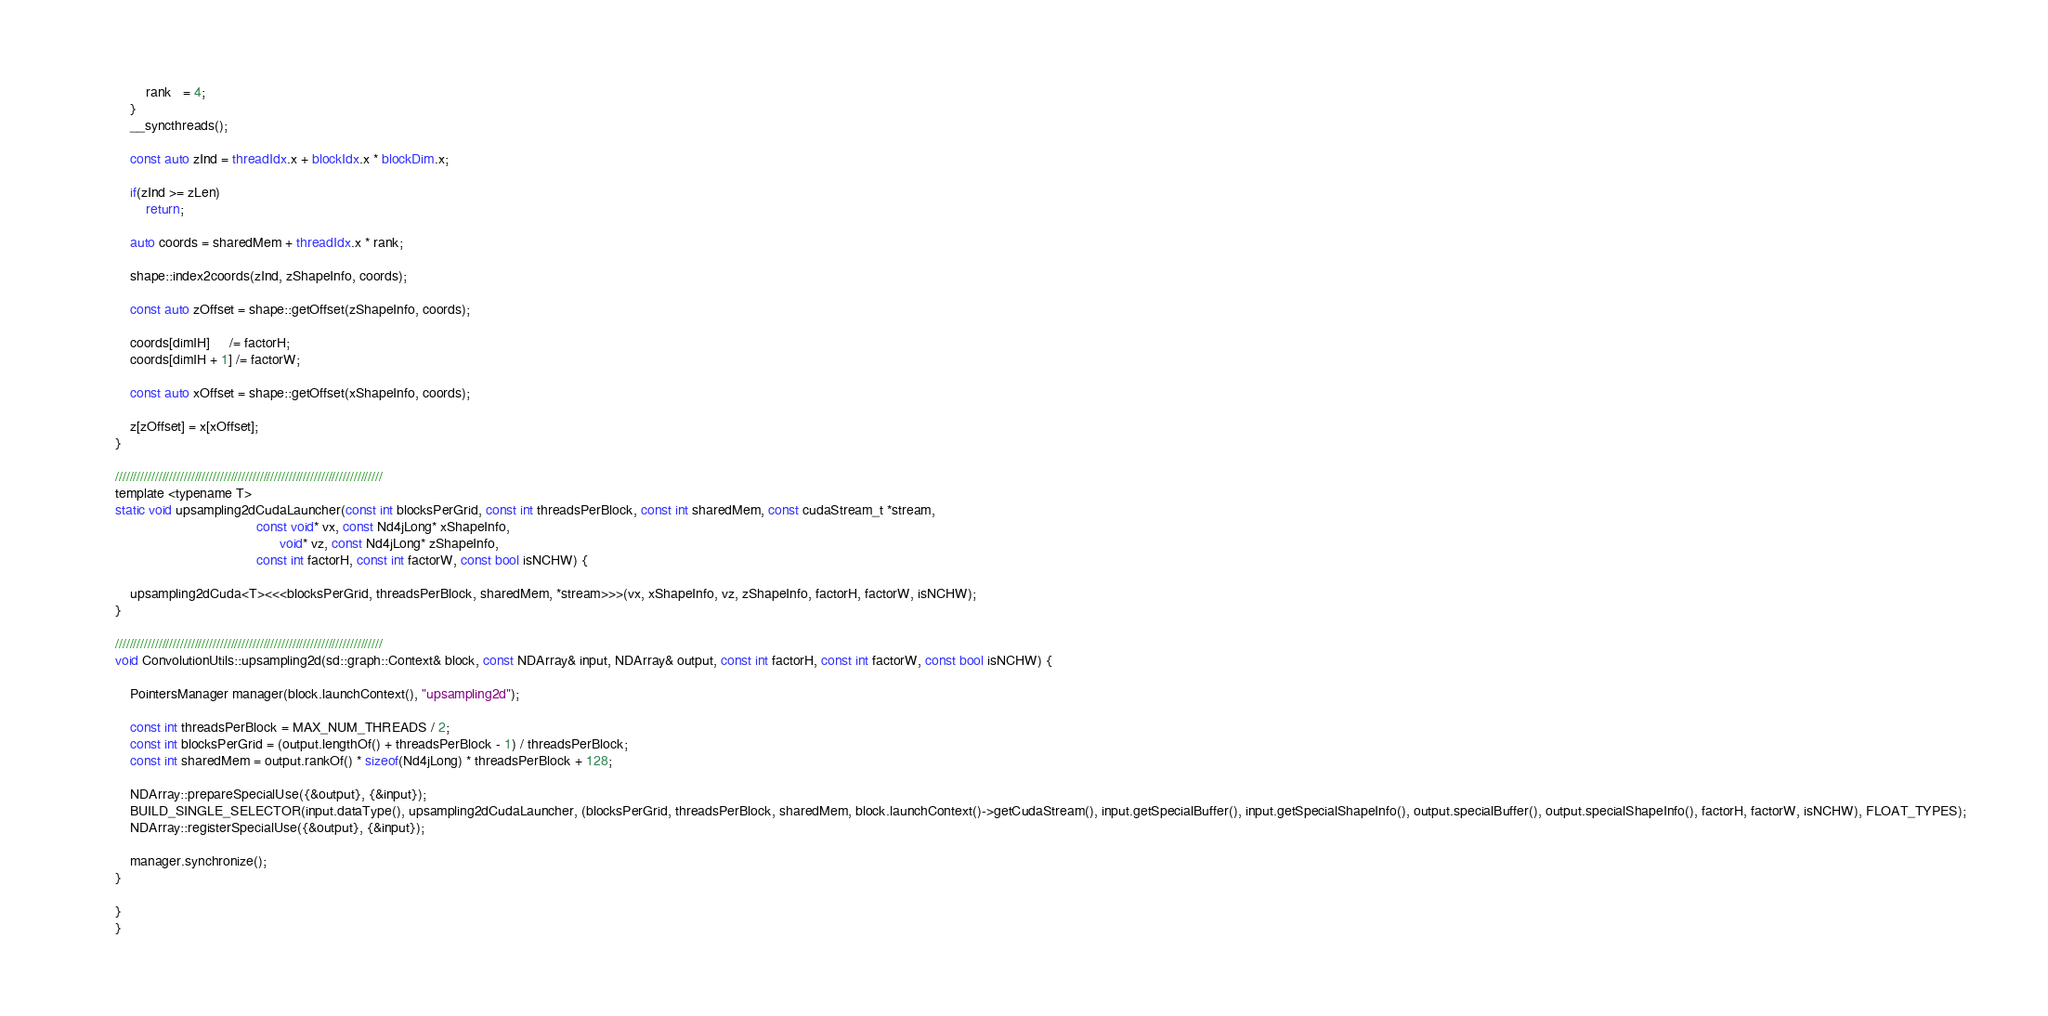<code> <loc_0><loc_0><loc_500><loc_500><_Cuda_>        rank   = 4;
    }
    __syncthreads();

    const auto zInd = threadIdx.x + blockIdx.x * blockDim.x;

    if(zInd >= zLen)
        return;

    auto coords = sharedMem + threadIdx.x * rank;

    shape::index2coords(zInd, zShapeInfo, coords);

    const auto zOffset = shape::getOffset(zShapeInfo, coords);

    coords[dimIH]     /= factorH;
    coords[dimIH + 1] /= factorW;

    const auto xOffset = shape::getOffset(xShapeInfo, coords);

    z[zOffset] = x[xOffset];
}

//////////////////////////////////////////////////////////////////////////
template <typename T>
static void upsampling2dCudaLauncher(const int blocksPerGrid, const int threadsPerBlock, const int sharedMem, const cudaStream_t *stream,
                                     const void* vx, const Nd4jLong* xShapeInfo,
                                           void* vz, const Nd4jLong* zShapeInfo,
                                     const int factorH, const int factorW, const bool isNCHW) {

    upsampling2dCuda<T><<<blocksPerGrid, threadsPerBlock, sharedMem, *stream>>>(vx, xShapeInfo, vz, zShapeInfo, factorH, factorW, isNCHW);
}

//////////////////////////////////////////////////////////////////////////
void ConvolutionUtils::upsampling2d(sd::graph::Context& block, const NDArray& input, NDArray& output, const int factorH, const int factorW, const bool isNCHW) {

    PointersManager manager(block.launchContext(), "upsampling2d");

    const int threadsPerBlock = MAX_NUM_THREADS / 2;
    const int blocksPerGrid = (output.lengthOf() + threadsPerBlock - 1) / threadsPerBlock;
    const int sharedMem = output.rankOf() * sizeof(Nd4jLong) * threadsPerBlock + 128;

    NDArray::prepareSpecialUse({&output}, {&input});
    BUILD_SINGLE_SELECTOR(input.dataType(), upsampling2dCudaLauncher, (blocksPerGrid, threadsPerBlock, sharedMem, block.launchContext()->getCudaStream(), input.getSpecialBuffer(), input.getSpecialShapeInfo(), output.specialBuffer(), output.specialShapeInfo(), factorH, factorW, isNCHW), FLOAT_TYPES);
    NDArray::registerSpecialUse({&output}, {&input});

    manager.synchronize();
}

}
}
</code> 